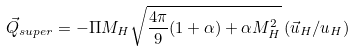Convert formula to latex. <formula><loc_0><loc_0><loc_500><loc_500>\vec { Q } _ { s u p e r } = - \Pi M _ { H } \sqrt { \frac { 4 \pi } { 9 } ( 1 + \alpha ) + \alpha M _ { H } ^ { 2 } } \left ( \vec { u } _ { H } / u _ { H } \right )</formula> 